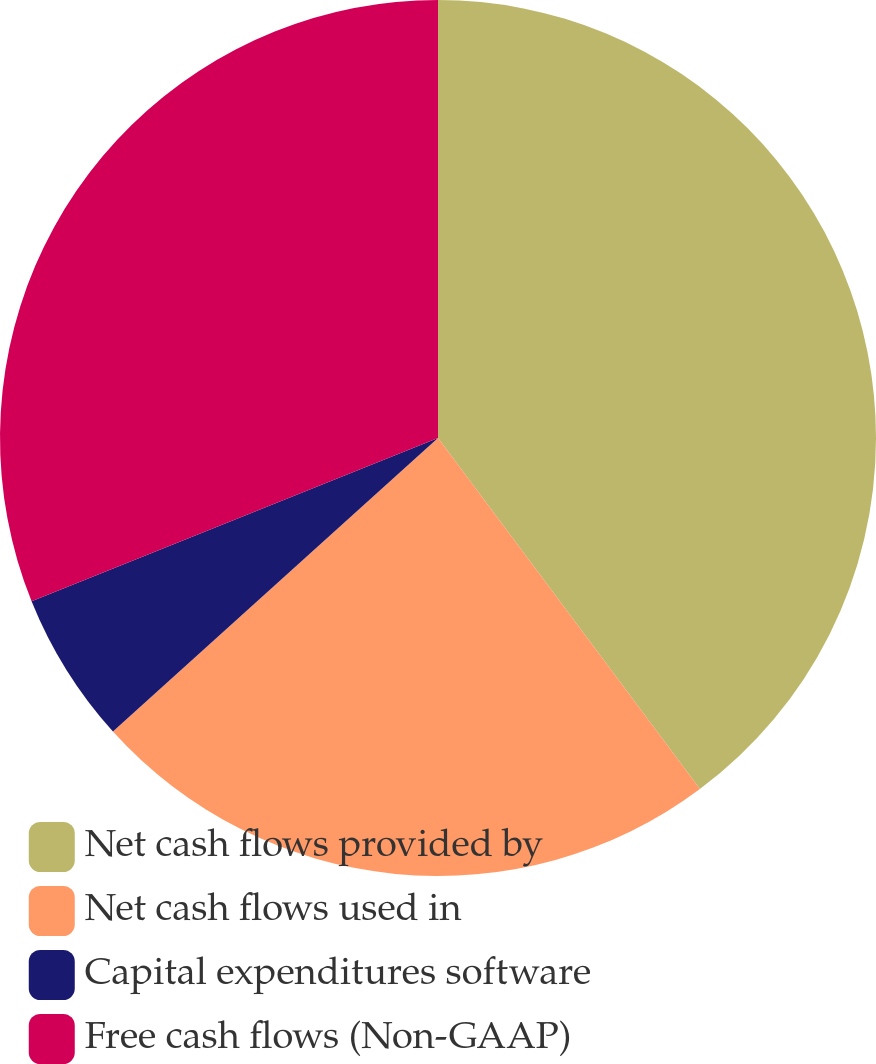Convert chart. <chart><loc_0><loc_0><loc_500><loc_500><pie_chart><fcel>Net cash flows provided by<fcel>Net cash flows used in<fcel>Capital expenditures software<fcel>Free cash flows (Non-GAAP)<nl><fcel>39.8%<fcel>23.51%<fcel>5.61%<fcel>31.08%<nl></chart> 